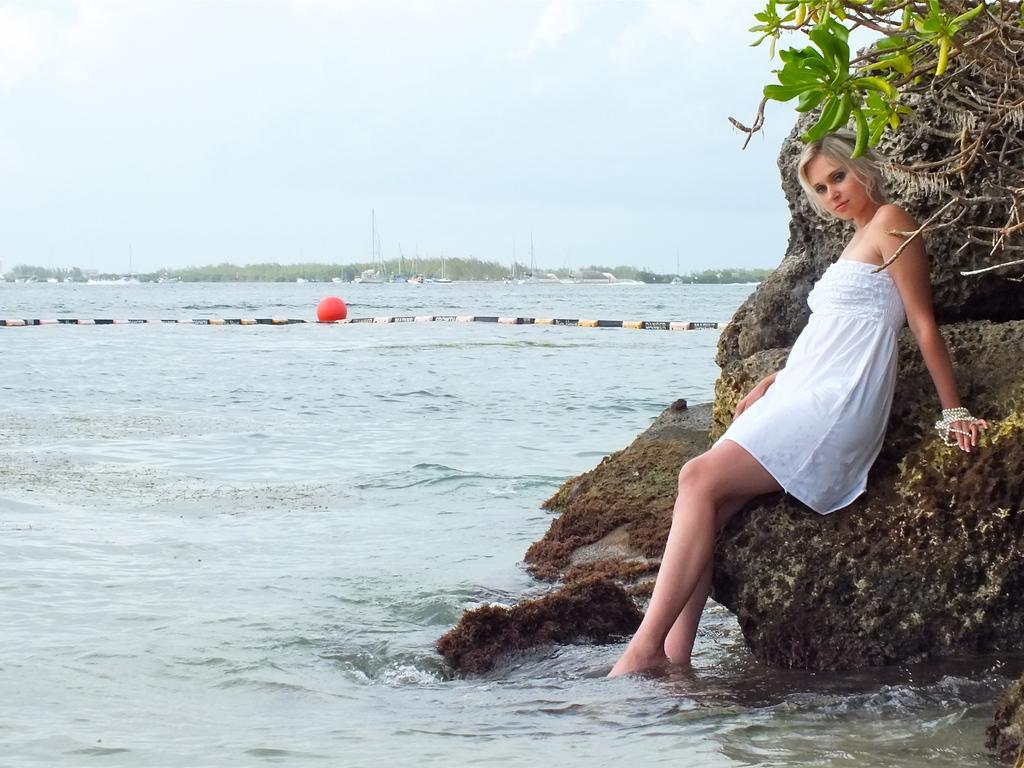Can you describe this image briefly? In this picture there is a woman who is wearing white dress. He is standing near to the water and stones. In the top right corner there is a tree. In the background i can see the poles, boards, trees, mountain and water. At the top i can see the sky and clouds. 